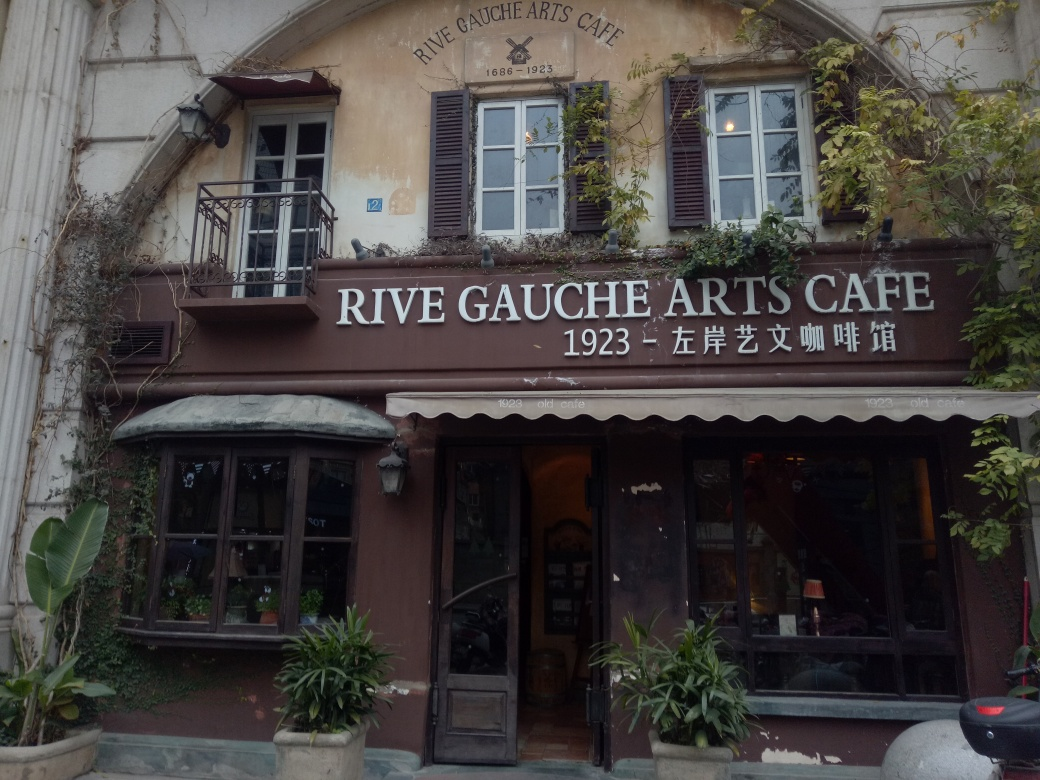How is the lighting in the image?
A. The lighting is uneven.
B. The lighting is even.
C. The lighting is too dim.
Answer with the option's letter from the given choices directly.
 B. 